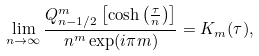Convert formula to latex. <formula><loc_0><loc_0><loc_500><loc_500>\lim _ { n \rightarrow \infty } \frac { Q _ { n - 1 / 2 } ^ { m } \left [ \cosh \left ( \frac { \tau } { n } \right ) \right ] } { n ^ { m } \exp ( i \pi m ) } = K _ { m } ( \tau ) ,</formula> 